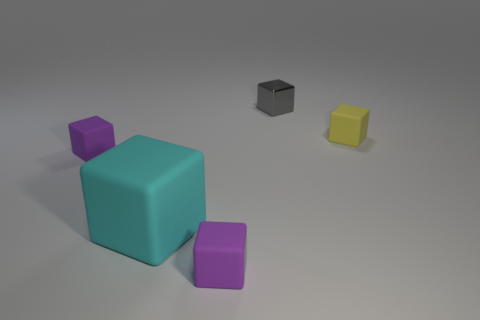Subtract 1 cubes. How many cubes are left? 4 Subtract all yellow blocks. How many blocks are left? 4 Subtract all tiny yellow matte blocks. How many blocks are left? 4 Subtract all green cubes. Subtract all purple cylinders. How many cubes are left? 5 Add 5 gray blocks. How many objects exist? 10 Add 4 metal objects. How many metal objects exist? 5 Subtract 0 green cubes. How many objects are left? 5 Subtract all purple rubber spheres. Subtract all big cyan things. How many objects are left? 4 Add 3 purple things. How many purple things are left? 5 